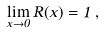<formula> <loc_0><loc_0><loc_500><loc_500>\lim _ { x \to 0 } R ( x ) = 1 \, ,</formula> 